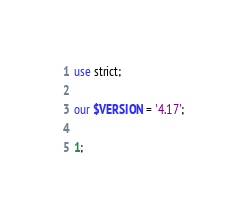<code> <loc_0><loc_0><loc_500><loc_500><_Perl_>
use strict;

our $VERSION = '4.17';

1;
</code> 